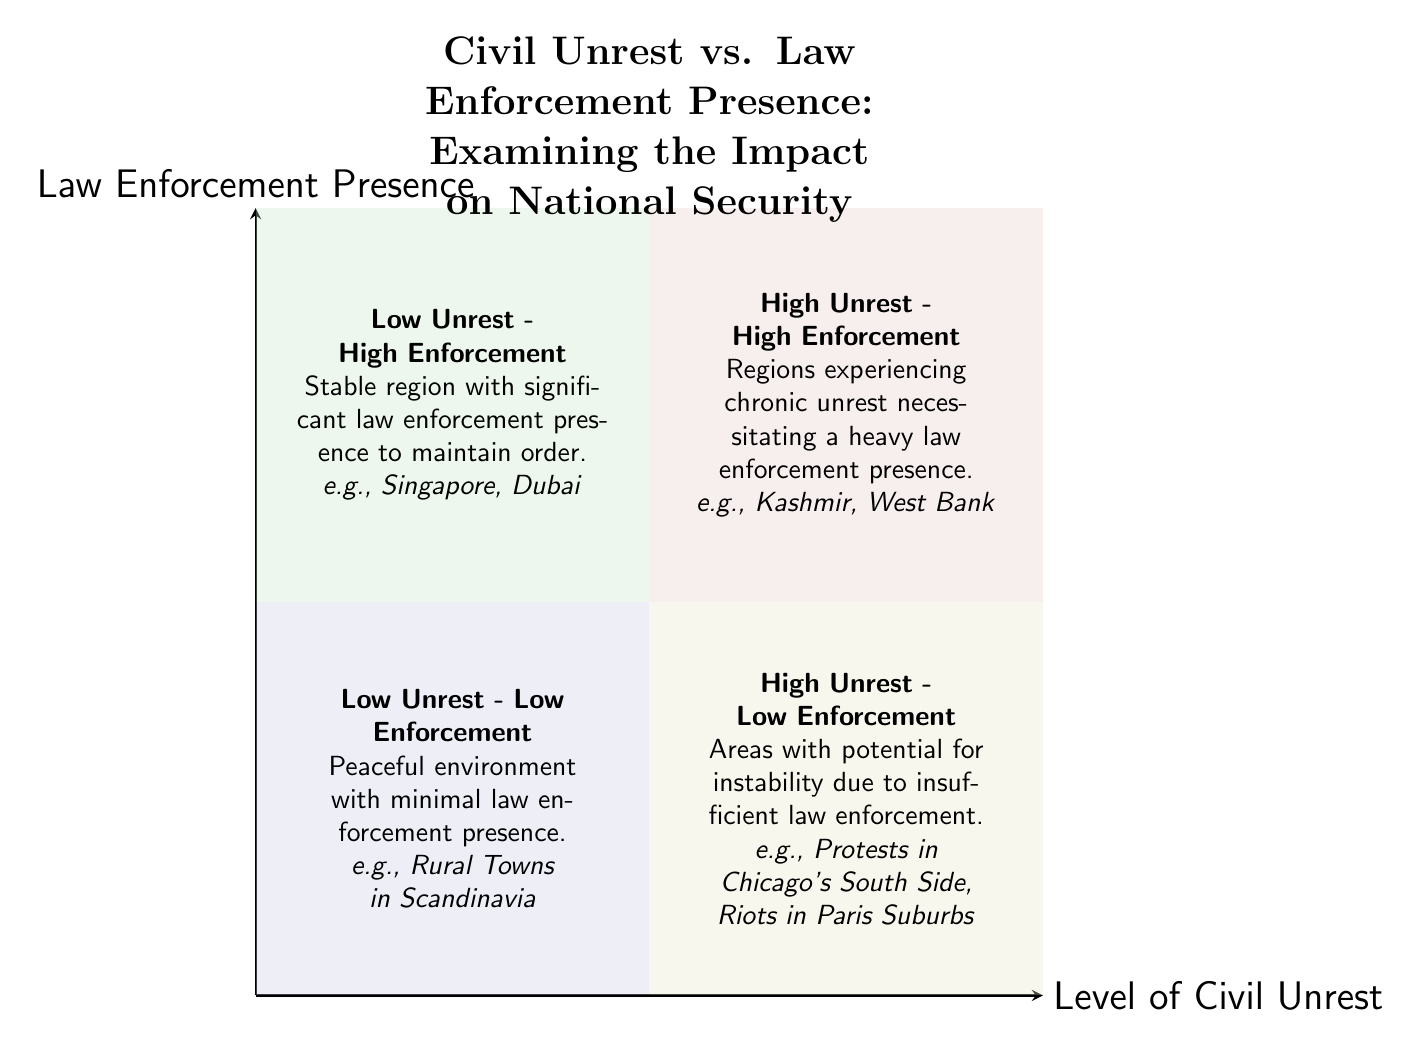What are the characteristics of the "Low Unrest - Low Enforcement" quadrant? The quadrant is described as a peaceful environment with minimal law enforcement presence, and it includes examples such as Rural Towns in Scandinavia.
Answer: Peaceful environment with minimal law enforcement presence Which quadrant features "Kashmir" as an example? Kashmir is listed as an example in the "High Unrest - High Enforcement" quadrant, which is characterized by chronic unrest necessitating a heavy law enforcement presence.
Answer: High Unrest - High Enforcement What type of environment does the "Low Unrest - High Enforcement" quadrant represent? This quadrant represents a stable region with significant law enforcement presence to maintain order and is exemplified by places like Singapore and Dubai.
Answer: Stable region with significant law enforcement presence How many quadrants are depicted in the chart? The diagram contains a total of four quadrants, each representing different combinations of civil unrest and law enforcement presence.
Answer: Four quadrants In which quadrant would you find areas with potential instability due to insufficient law enforcement? Areas with potential instability due to insufficient law enforcement are located in the "High Unrest - Low Enforcement" quadrant, which highlights the risks associated with low law enforcement in high unrest areas.
Answer: High Unrest - Low Enforcement Which quadrant has examples of "Riots in Paris Suburbs"? "Riots in Paris Suburbs" are examples found in the "High Unrest - Low Enforcement" quadrant, indicating a situation where there is significant unrest but insufficient law enforcement.
Answer: High Unrest - Low Enforcement What is the title of the diagram? The title of the diagram is "Civil Unrest vs. Law Enforcement Presence: Examining the Impact on National Security."
Answer: Civil Unrest vs. Law Enforcement Presence: Examining the Impact on National Security Which quadrant experiences both high levels of unrest and enforces a heavy law presence? The "High Unrest - High Enforcement" quadrant is where both high levels of civil unrest are coupled with a significant law enforcement presence to address this unrest.
Answer: High Unrest - High Enforcement 